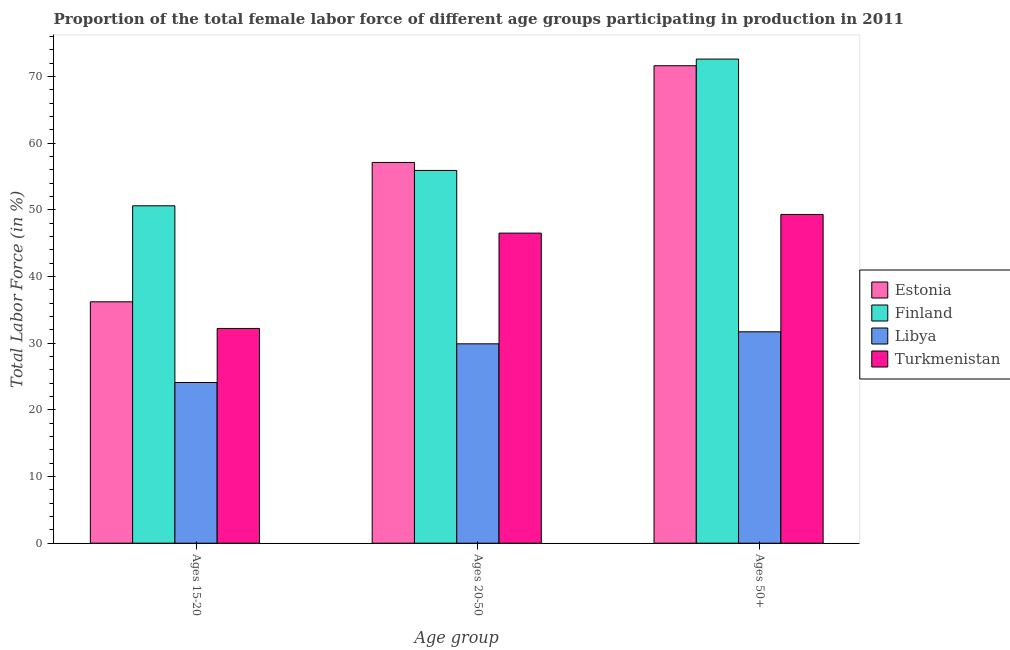How many different coloured bars are there?
Your answer should be very brief. 4. How many groups of bars are there?
Provide a short and direct response. 3. Are the number of bars on each tick of the X-axis equal?
Provide a short and direct response. Yes. How many bars are there on the 3rd tick from the left?
Give a very brief answer. 4. What is the label of the 2nd group of bars from the left?
Offer a very short reply. Ages 20-50. What is the percentage of female labor force above age 50 in Estonia?
Offer a terse response. 71.6. Across all countries, what is the maximum percentage of female labor force within the age group 15-20?
Offer a very short reply. 50.6. Across all countries, what is the minimum percentage of female labor force above age 50?
Keep it short and to the point. 31.7. In which country was the percentage of female labor force within the age group 20-50 maximum?
Provide a short and direct response. Estonia. In which country was the percentage of female labor force above age 50 minimum?
Ensure brevity in your answer.  Libya. What is the total percentage of female labor force above age 50 in the graph?
Provide a succinct answer. 225.2. What is the difference between the percentage of female labor force above age 50 in Finland and that in Libya?
Provide a short and direct response. 40.9. What is the difference between the percentage of female labor force within the age group 20-50 in Finland and the percentage of female labor force above age 50 in Estonia?
Offer a very short reply. -15.7. What is the average percentage of female labor force above age 50 per country?
Your response must be concise. 56.3. What is the difference between the percentage of female labor force within the age group 15-20 and percentage of female labor force within the age group 20-50 in Estonia?
Ensure brevity in your answer.  -20.9. What is the ratio of the percentage of female labor force within the age group 15-20 in Finland to that in Libya?
Keep it short and to the point. 2.1. Is the difference between the percentage of female labor force within the age group 20-50 in Finland and Turkmenistan greater than the difference between the percentage of female labor force within the age group 15-20 in Finland and Turkmenistan?
Keep it short and to the point. No. What is the difference between the highest and the second highest percentage of female labor force above age 50?
Provide a short and direct response. 1. What is the difference between the highest and the lowest percentage of female labor force above age 50?
Make the answer very short. 40.9. What does the 2nd bar from the left in Ages 20-50 represents?
Offer a very short reply. Finland. What does the 4th bar from the right in Ages 20-50 represents?
Provide a short and direct response. Estonia. Is it the case that in every country, the sum of the percentage of female labor force within the age group 15-20 and percentage of female labor force within the age group 20-50 is greater than the percentage of female labor force above age 50?
Offer a terse response. Yes. Are all the bars in the graph horizontal?
Make the answer very short. No. How many countries are there in the graph?
Provide a short and direct response. 4. What is the difference between two consecutive major ticks on the Y-axis?
Give a very brief answer. 10. Are the values on the major ticks of Y-axis written in scientific E-notation?
Offer a terse response. No. Where does the legend appear in the graph?
Make the answer very short. Center right. What is the title of the graph?
Provide a short and direct response. Proportion of the total female labor force of different age groups participating in production in 2011. What is the label or title of the X-axis?
Offer a very short reply. Age group. What is the Total Labor Force (in %) in Estonia in Ages 15-20?
Provide a short and direct response. 36.2. What is the Total Labor Force (in %) in Finland in Ages 15-20?
Ensure brevity in your answer.  50.6. What is the Total Labor Force (in %) in Libya in Ages 15-20?
Offer a very short reply. 24.1. What is the Total Labor Force (in %) in Turkmenistan in Ages 15-20?
Your response must be concise. 32.2. What is the Total Labor Force (in %) of Estonia in Ages 20-50?
Your response must be concise. 57.1. What is the Total Labor Force (in %) of Finland in Ages 20-50?
Your answer should be very brief. 55.9. What is the Total Labor Force (in %) of Libya in Ages 20-50?
Provide a succinct answer. 29.9. What is the Total Labor Force (in %) in Turkmenistan in Ages 20-50?
Your answer should be compact. 46.5. What is the Total Labor Force (in %) of Estonia in Ages 50+?
Provide a short and direct response. 71.6. What is the Total Labor Force (in %) in Finland in Ages 50+?
Offer a very short reply. 72.6. What is the Total Labor Force (in %) of Libya in Ages 50+?
Your response must be concise. 31.7. What is the Total Labor Force (in %) in Turkmenistan in Ages 50+?
Make the answer very short. 49.3. Across all Age group, what is the maximum Total Labor Force (in %) of Estonia?
Provide a short and direct response. 71.6. Across all Age group, what is the maximum Total Labor Force (in %) in Finland?
Ensure brevity in your answer.  72.6. Across all Age group, what is the maximum Total Labor Force (in %) in Libya?
Your response must be concise. 31.7. Across all Age group, what is the maximum Total Labor Force (in %) in Turkmenistan?
Your answer should be compact. 49.3. Across all Age group, what is the minimum Total Labor Force (in %) of Estonia?
Provide a short and direct response. 36.2. Across all Age group, what is the minimum Total Labor Force (in %) in Finland?
Ensure brevity in your answer.  50.6. Across all Age group, what is the minimum Total Labor Force (in %) in Libya?
Provide a succinct answer. 24.1. Across all Age group, what is the minimum Total Labor Force (in %) of Turkmenistan?
Make the answer very short. 32.2. What is the total Total Labor Force (in %) of Estonia in the graph?
Give a very brief answer. 164.9. What is the total Total Labor Force (in %) in Finland in the graph?
Make the answer very short. 179.1. What is the total Total Labor Force (in %) of Libya in the graph?
Give a very brief answer. 85.7. What is the total Total Labor Force (in %) in Turkmenistan in the graph?
Provide a short and direct response. 128. What is the difference between the Total Labor Force (in %) in Estonia in Ages 15-20 and that in Ages 20-50?
Provide a short and direct response. -20.9. What is the difference between the Total Labor Force (in %) of Finland in Ages 15-20 and that in Ages 20-50?
Give a very brief answer. -5.3. What is the difference between the Total Labor Force (in %) in Libya in Ages 15-20 and that in Ages 20-50?
Your answer should be compact. -5.8. What is the difference between the Total Labor Force (in %) of Turkmenistan in Ages 15-20 and that in Ages 20-50?
Offer a very short reply. -14.3. What is the difference between the Total Labor Force (in %) of Estonia in Ages 15-20 and that in Ages 50+?
Keep it short and to the point. -35.4. What is the difference between the Total Labor Force (in %) in Libya in Ages 15-20 and that in Ages 50+?
Give a very brief answer. -7.6. What is the difference between the Total Labor Force (in %) of Turkmenistan in Ages 15-20 and that in Ages 50+?
Provide a short and direct response. -17.1. What is the difference between the Total Labor Force (in %) in Finland in Ages 20-50 and that in Ages 50+?
Your answer should be compact. -16.7. What is the difference between the Total Labor Force (in %) in Turkmenistan in Ages 20-50 and that in Ages 50+?
Your answer should be compact. -2.8. What is the difference between the Total Labor Force (in %) of Estonia in Ages 15-20 and the Total Labor Force (in %) of Finland in Ages 20-50?
Your answer should be compact. -19.7. What is the difference between the Total Labor Force (in %) of Finland in Ages 15-20 and the Total Labor Force (in %) of Libya in Ages 20-50?
Offer a very short reply. 20.7. What is the difference between the Total Labor Force (in %) in Finland in Ages 15-20 and the Total Labor Force (in %) in Turkmenistan in Ages 20-50?
Your response must be concise. 4.1. What is the difference between the Total Labor Force (in %) in Libya in Ages 15-20 and the Total Labor Force (in %) in Turkmenistan in Ages 20-50?
Give a very brief answer. -22.4. What is the difference between the Total Labor Force (in %) of Estonia in Ages 15-20 and the Total Labor Force (in %) of Finland in Ages 50+?
Ensure brevity in your answer.  -36.4. What is the difference between the Total Labor Force (in %) of Estonia in Ages 15-20 and the Total Labor Force (in %) of Libya in Ages 50+?
Your response must be concise. 4.5. What is the difference between the Total Labor Force (in %) in Finland in Ages 15-20 and the Total Labor Force (in %) in Libya in Ages 50+?
Your answer should be very brief. 18.9. What is the difference between the Total Labor Force (in %) in Finland in Ages 15-20 and the Total Labor Force (in %) in Turkmenistan in Ages 50+?
Offer a very short reply. 1.3. What is the difference between the Total Labor Force (in %) of Libya in Ages 15-20 and the Total Labor Force (in %) of Turkmenistan in Ages 50+?
Provide a succinct answer. -25.2. What is the difference between the Total Labor Force (in %) of Estonia in Ages 20-50 and the Total Labor Force (in %) of Finland in Ages 50+?
Your answer should be very brief. -15.5. What is the difference between the Total Labor Force (in %) in Estonia in Ages 20-50 and the Total Labor Force (in %) in Libya in Ages 50+?
Offer a very short reply. 25.4. What is the difference between the Total Labor Force (in %) in Finland in Ages 20-50 and the Total Labor Force (in %) in Libya in Ages 50+?
Provide a succinct answer. 24.2. What is the difference between the Total Labor Force (in %) in Libya in Ages 20-50 and the Total Labor Force (in %) in Turkmenistan in Ages 50+?
Offer a very short reply. -19.4. What is the average Total Labor Force (in %) of Estonia per Age group?
Your response must be concise. 54.97. What is the average Total Labor Force (in %) in Finland per Age group?
Your response must be concise. 59.7. What is the average Total Labor Force (in %) in Libya per Age group?
Your answer should be very brief. 28.57. What is the average Total Labor Force (in %) of Turkmenistan per Age group?
Your answer should be compact. 42.67. What is the difference between the Total Labor Force (in %) in Estonia and Total Labor Force (in %) in Finland in Ages 15-20?
Provide a succinct answer. -14.4. What is the difference between the Total Labor Force (in %) in Estonia and Total Labor Force (in %) in Turkmenistan in Ages 15-20?
Make the answer very short. 4. What is the difference between the Total Labor Force (in %) in Finland and Total Labor Force (in %) in Libya in Ages 15-20?
Ensure brevity in your answer.  26.5. What is the difference between the Total Labor Force (in %) of Finland and Total Labor Force (in %) of Turkmenistan in Ages 15-20?
Give a very brief answer. 18.4. What is the difference between the Total Labor Force (in %) in Libya and Total Labor Force (in %) in Turkmenistan in Ages 15-20?
Ensure brevity in your answer.  -8.1. What is the difference between the Total Labor Force (in %) of Estonia and Total Labor Force (in %) of Libya in Ages 20-50?
Your answer should be compact. 27.2. What is the difference between the Total Labor Force (in %) of Estonia and Total Labor Force (in %) of Turkmenistan in Ages 20-50?
Make the answer very short. 10.6. What is the difference between the Total Labor Force (in %) in Libya and Total Labor Force (in %) in Turkmenistan in Ages 20-50?
Make the answer very short. -16.6. What is the difference between the Total Labor Force (in %) in Estonia and Total Labor Force (in %) in Libya in Ages 50+?
Offer a very short reply. 39.9. What is the difference between the Total Labor Force (in %) in Estonia and Total Labor Force (in %) in Turkmenistan in Ages 50+?
Provide a succinct answer. 22.3. What is the difference between the Total Labor Force (in %) of Finland and Total Labor Force (in %) of Libya in Ages 50+?
Make the answer very short. 40.9. What is the difference between the Total Labor Force (in %) of Finland and Total Labor Force (in %) of Turkmenistan in Ages 50+?
Offer a terse response. 23.3. What is the difference between the Total Labor Force (in %) in Libya and Total Labor Force (in %) in Turkmenistan in Ages 50+?
Your answer should be very brief. -17.6. What is the ratio of the Total Labor Force (in %) of Estonia in Ages 15-20 to that in Ages 20-50?
Make the answer very short. 0.63. What is the ratio of the Total Labor Force (in %) of Finland in Ages 15-20 to that in Ages 20-50?
Provide a short and direct response. 0.91. What is the ratio of the Total Labor Force (in %) in Libya in Ages 15-20 to that in Ages 20-50?
Your answer should be very brief. 0.81. What is the ratio of the Total Labor Force (in %) in Turkmenistan in Ages 15-20 to that in Ages 20-50?
Provide a succinct answer. 0.69. What is the ratio of the Total Labor Force (in %) in Estonia in Ages 15-20 to that in Ages 50+?
Your answer should be compact. 0.51. What is the ratio of the Total Labor Force (in %) in Finland in Ages 15-20 to that in Ages 50+?
Give a very brief answer. 0.7. What is the ratio of the Total Labor Force (in %) in Libya in Ages 15-20 to that in Ages 50+?
Your response must be concise. 0.76. What is the ratio of the Total Labor Force (in %) in Turkmenistan in Ages 15-20 to that in Ages 50+?
Make the answer very short. 0.65. What is the ratio of the Total Labor Force (in %) in Estonia in Ages 20-50 to that in Ages 50+?
Your response must be concise. 0.8. What is the ratio of the Total Labor Force (in %) of Finland in Ages 20-50 to that in Ages 50+?
Offer a terse response. 0.77. What is the ratio of the Total Labor Force (in %) of Libya in Ages 20-50 to that in Ages 50+?
Make the answer very short. 0.94. What is the ratio of the Total Labor Force (in %) in Turkmenistan in Ages 20-50 to that in Ages 50+?
Offer a very short reply. 0.94. What is the difference between the highest and the second highest Total Labor Force (in %) of Estonia?
Your answer should be very brief. 14.5. What is the difference between the highest and the second highest Total Labor Force (in %) in Finland?
Make the answer very short. 16.7. What is the difference between the highest and the second highest Total Labor Force (in %) in Turkmenistan?
Make the answer very short. 2.8. What is the difference between the highest and the lowest Total Labor Force (in %) in Estonia?
Provide a short and direct response. 35.4. 